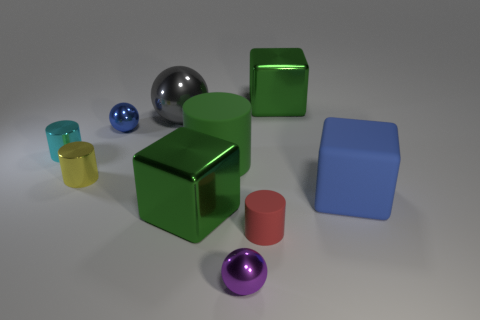Subtract all blocks. How many objects are left? 7 Subtract all purple metal balls. Subtract all small matte things. How many objects are left? 8 Add 7 big green shiny cubes. How many big green shiny cubes are left? 9 Add 7 small cyan metal things. How many small cyan metal things exist? 8 Subtract 0 brown spheres. How many objects are left? 10 